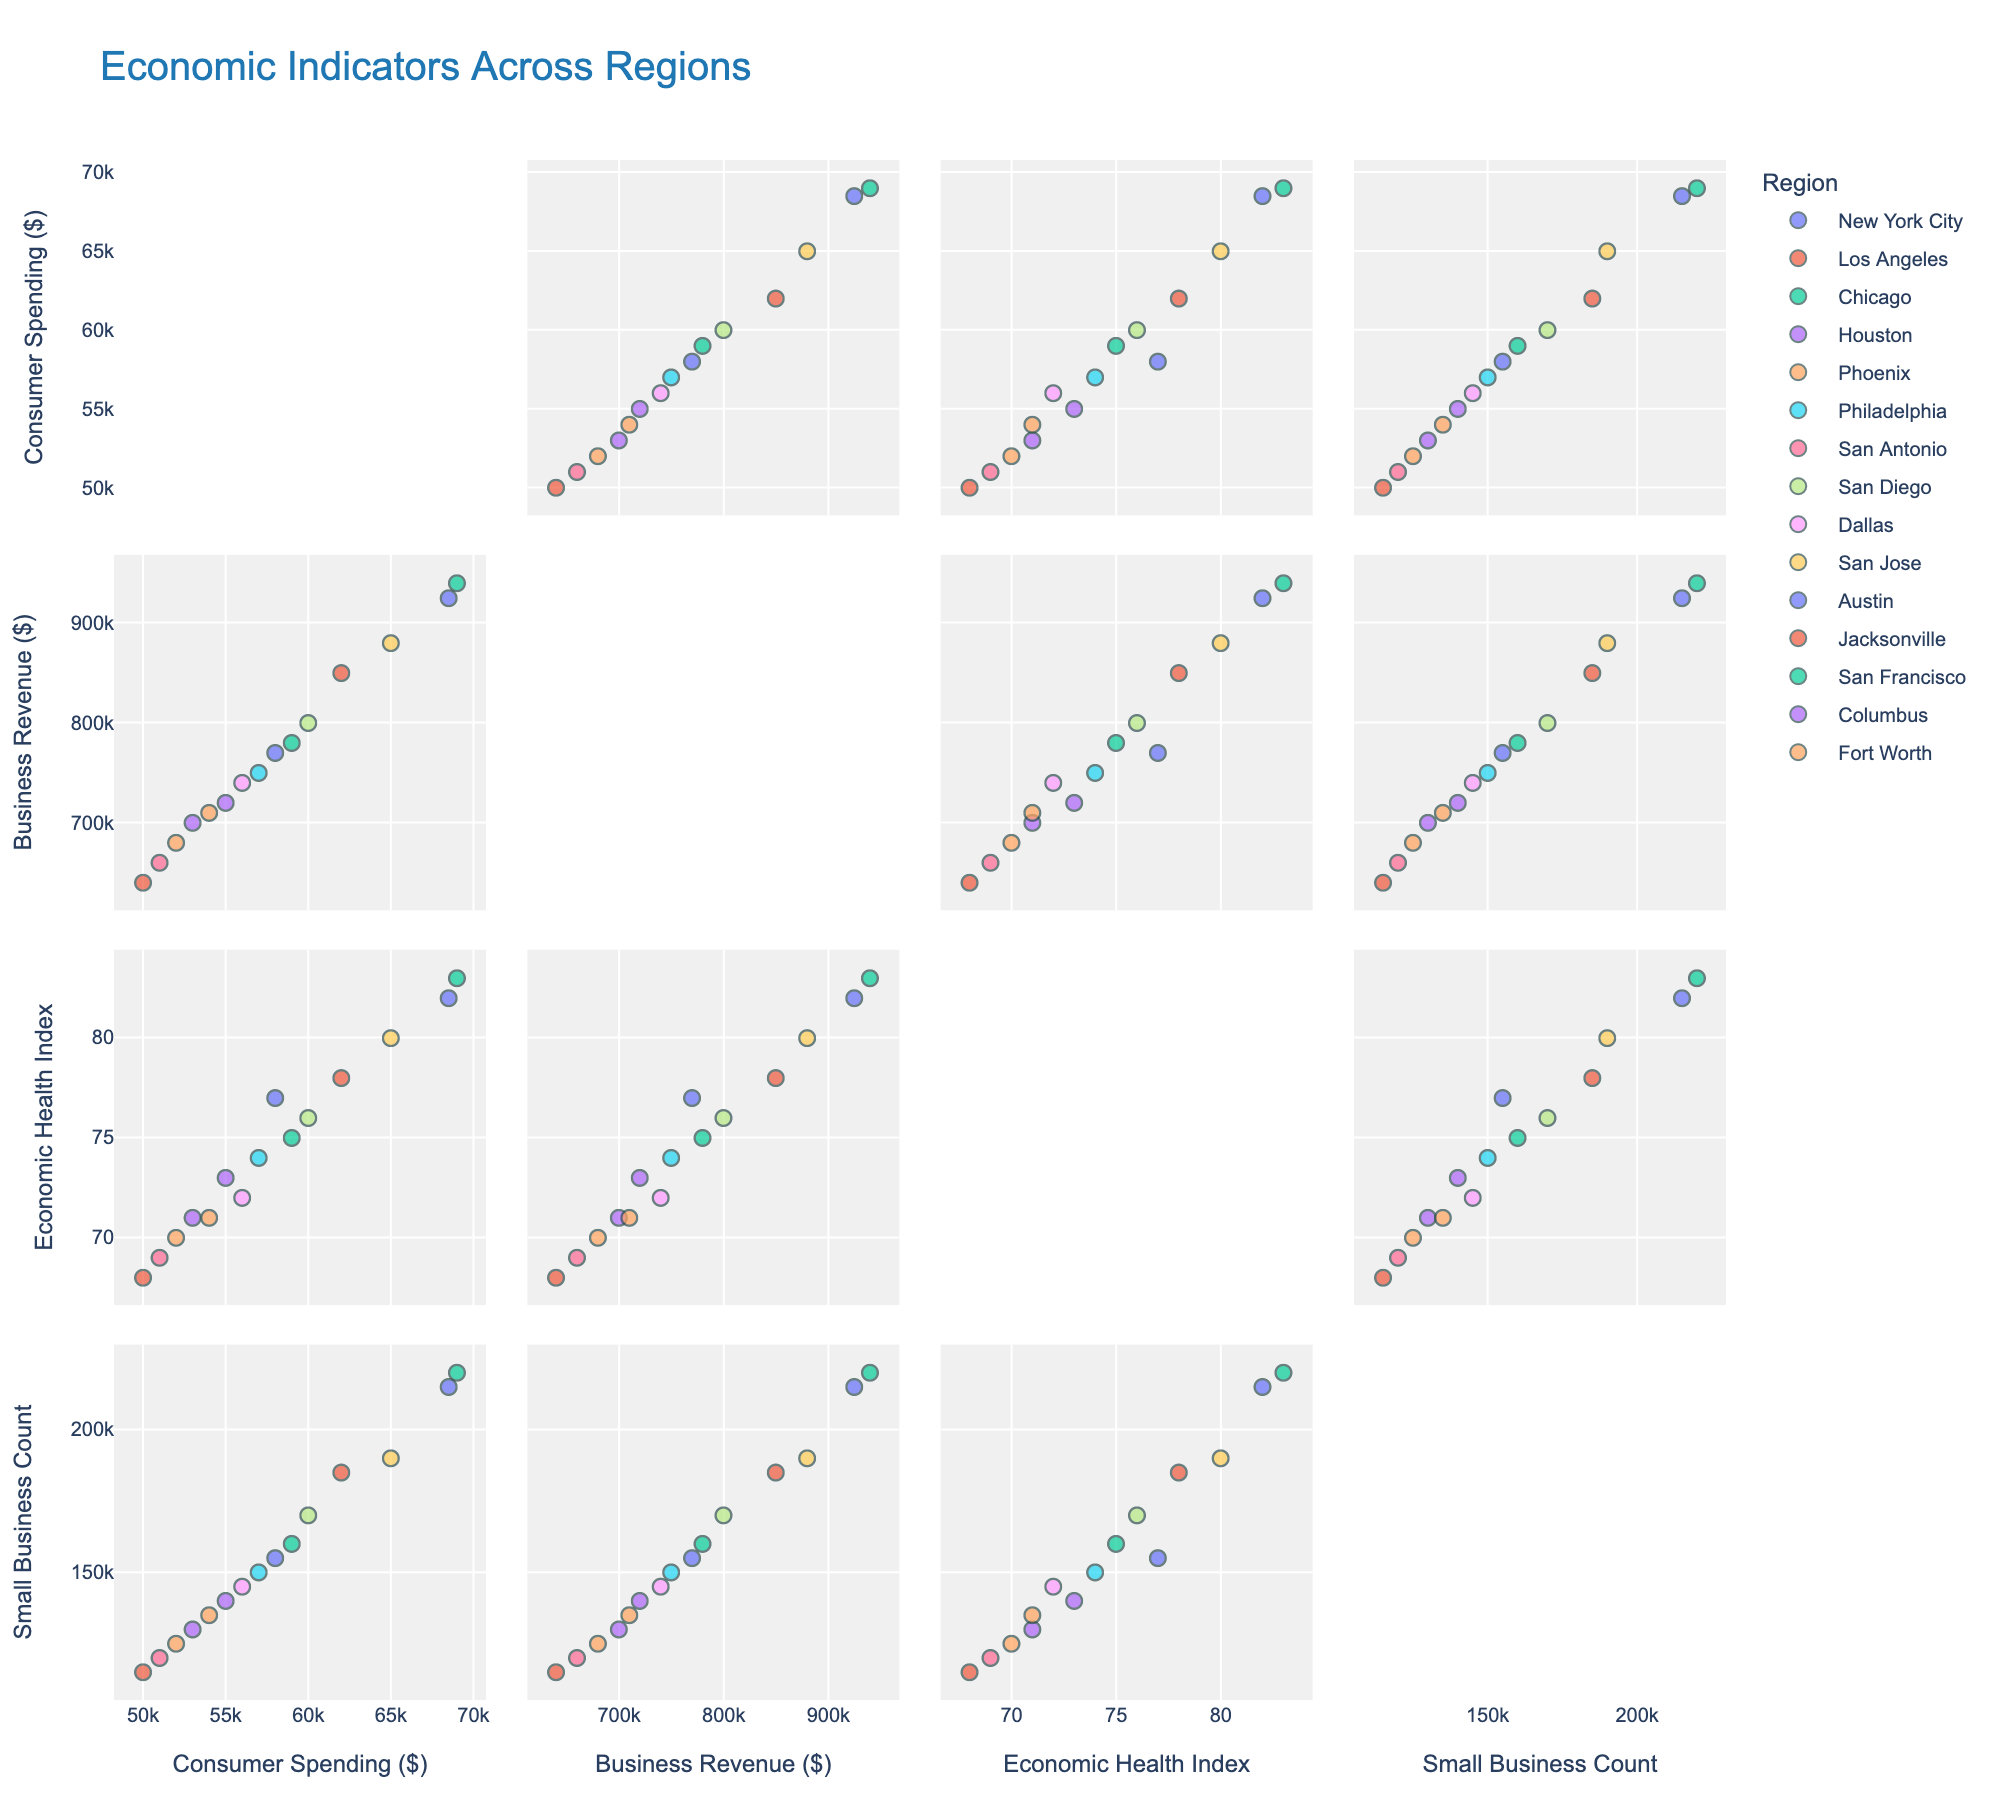What is the title of the figure? The title of a figure is usually displayed at the top of the chart. In this case, the title is "Economic Indicators Across Regions".
Answer: Economic Indicators Across Regions How many dimensions (variables) are displayed in the scatter plot matrix? To determine the number of dimensions, count the number of unique variables that appear on the axes of the scatter plot matrix. There are four dimensions: Consumer Spending, Business Revenue, Economic Health Index, and Small Business Count.
Answer: Four Which region has the highest Business Revenue? To find this, look at the scatter plots involving Business Revenue and identify the region with the highest value. San Francisco has the highest Business Revenue.
Answer: San Francisco What is the relationship between Consumer Spending and Business Revenue? Examine the scatter plot where Consumer Spending is on one axis and Business Revenue is on the other. Look for any trends or patterns. There's a positive correlation: as Consumer Spending increases, Business Revenue also tends to increase.
Answer: Positive correlation Which region appears to have the best overall Economic Health Index? Check the scatter plots involving the Economic Health Index and identify the region with the highest value. San Francisco has the highest Economic Health Index.
Answer: San Francisco How does the number of Small Businesses relate to the Economic Health Index? Look at the scatter plots where Small Business Count and Economic Health Index are plotted against each other. Generally, regions with higher Small Business Counts tend to have higher Economic Health Index values, indicating a positive correlation.
Answer: Positive correlation Compare Consumer Spending between New York City and Los Angeles. Which region spends more? Identify the Consumer Spending values for New York City and Los Angeles from the scatter plot matrix. New York City's Consumer Spending is 68500, while Los Angeles is 62000. New York City spends more.
Answer: New York City What is the relationship between Small Business Count and Business Revenue? Review the scatter plots where Small Business Count and Business Revenue are plotted against each other to observe any trends. There is a positive correlation: regions with more Small Businesses generally have higher Business Revenues.
Answer: Positive correlation Which region has the lowest Consumer Spending value? Look at the Consumer Spending dimension in the scatter plot matrix and identify the region with the smallest value. Jacksonville has the lowest Consumer Spending value of 50000.
Answer: Jacksonville 